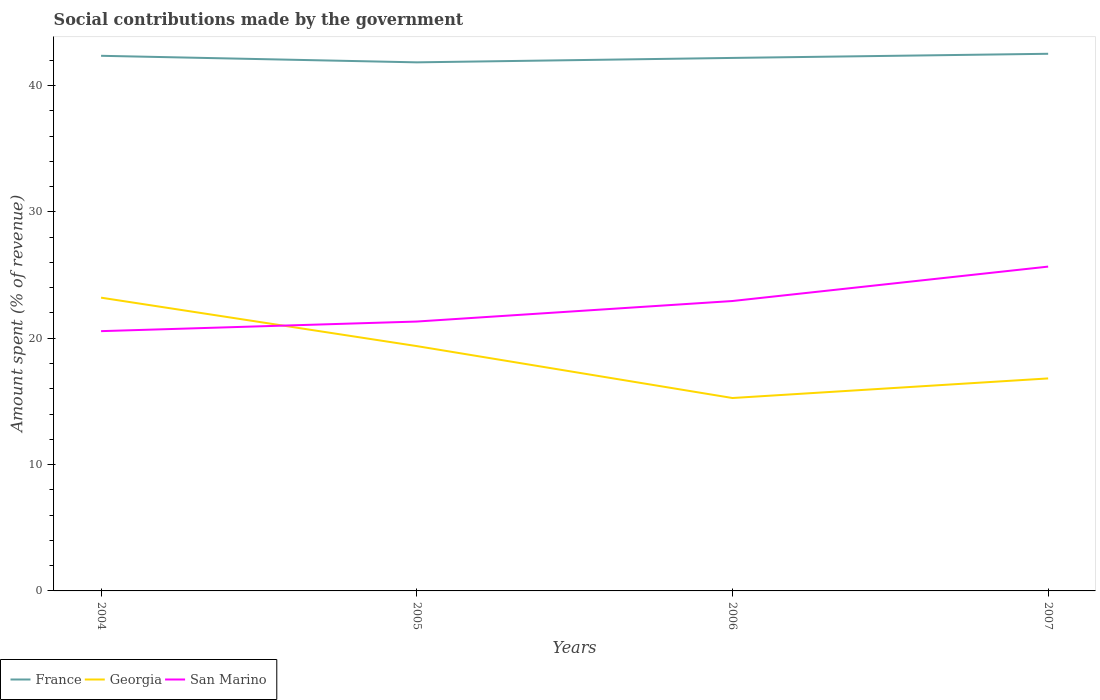How many different coloured lines are there?
Your response must be concise. 3. Is the number of lines equal to the number of legend labels?
Give a very brief answer. Yes. Across all years, what is the maximum amount spent (in %) on social contributions in Georgia?
Keep it short and to the point. 15.27. In which year was the amount spent (in %) on social contributions in San Marino maximum?
Give a very brief answer. 2004. What is the total amount spent (in %) on social contributions in France in the graph?
Ensure brevity in your answer.  -0.16. What is the difference between the highest and the second highest amount spent (in %) on social contributions in San Marino?
Provide a short and direct response. 5.11. What is the difference between the highest and the lowest amount spent (in %) on social contributions in France?
Make the answer very short. 2. What is the difference between two consecutive major ticks on the Y-axis?
Offer a terse response. 10. Does the graph contain grids?
Make the answer very short. No. How many legend labels are there?
Offer a terse response. 3. What is the title of the graph?
Ensure brevity in your answer.  Social contributions made by the government. What is the label or title of the X-axis?
Ensure brevity in your answer.  Years. What is the label or title of the Y-axis?
Your answer should be very brief. Amount spent (% of revenue). What is the Amount spent (% of revenue) of France in 2004?
Offer a terse response. 42.35. What is the Amount spent (% of revenue) of Georgia in 2004?
Your answer should be very brief. 23.21. What is the Amount spent (% of revenue) of San Marino in 2004?
Offer a terse response. 20.56. What is the Amount spent (% of revenue) of France in 2005?
Provide a succinct answer. 41.83. What is the Amount spent (% of revenue) of Georgia in 2005?
Keep it short and to the point. 19.38. What is the Amount spent (% of revenue) of San Marino in 2005?
Ensure brevity in your answer.  21.32. What is the Amount spent (% of revenue) in France in 2006?
Your answer should be very brief. 42.18. What is the Amount spent (% of revenue) in Georgia in 2006?
Your answer should be very brief. 15.27. What is the Amount spent (% of revenue) in San Marino in 2006?
Provide a succinct answer. 22.94. What is the Amount spent (% of revenue) of France in 2007?
Provide a succinct answer. 42.51. What is the Amount spent (% of revenue) in Georgia in 2007?
Your response must be concise. 16.82. What is the Amount spent (% of revenue) in San Marino in 2007?
Offer a terse response. 25.67. Across all years, what is the maximum Amount spent (% of revenue) of France?
Offer a terse response. 42.51. Across all years, what is the maximum Amount spent (% of revenue) in Georgia?
Ensure brevity in your answer.  23.21. Across all years, what is the maximum Amount spent (% of revenue) in San Marino?
Give a very brief answer. 25.67. Across all years, what is the minimum Amount spent (% of revenue) in France?
Keep it short and to the point. 41.83. Across all years, what is the minimum Amount spent (% of revenue) in Georgia?
Offer a terse response. 15.27. Across all years, what is the minimum Amount spent (% of revenue) of San Marino?
Your answer should be very brief. 20.56. What is the total Amount spent (% of revenue) in France in the graph?
Keep it short and to the point. 168.88. What is the total Amount spent (% of revenue) of Georgia in the graph?
Ensure brevity in your answer.  74.67. What is the total Amount spent (% of revenue) in San Marino in the graph?
Your answer should be compact. 90.49. What is the difference between the Amount spent (% of revenue) in France in 2004 and that in 2005?
Offer a terse response. 0.52. What is the difference between the Amount spent (% of revenue) of Georgia in 2004 and that in 2005?
Your answer should be very brief. 3.83. What is the difference between the Amount spent (% of revenue) of San Marino in 2004 and that in 2005?
Provide a succinct answer. -0.76. What is the difference between the Amount spent (% of revenue) in France in 2004 and that in 2006?
Keep it short and to the point. 0.17. What is the difference between the Amount spent (% of revenue) of Georgia in 2004 and that in 2006?
Your answer should be very brief. 7.94. What is the difference between the Amount spent (% of revenue) of San Marino in 2004 and that in 2006?
Make the answer very short. -2.39. What is the difference between the Amount spent (% of revenue) of France in 2004 and that in 2007?
Keep it short and to the point. -0.16. What is the difference between the Amount spent (% of revenue) in Georgia in 2004 and that in 2007?
Offer a terse response. 6.39. What is the difference between the Amount spent (% of revenue) in San Marino in 2004 and that in 2007?
Offer a very short reply. -5.11. What is the difference between the Amount spent (% of revenue) in France in 2005 and that in 2006?
Provide a short and direct response. -0.35. What is the difference between the Amount spent (% of revenue) of Georgia in 2005 and that in 2006?
Offer a very short reply. 4.11. What is the difference between the Amount spent (% of revenue) in San Marino in 2005 and that in 2006?
Your response must be concise. -1.62. What is the difference between the Amount spent (% of revenue) of France in 2005 and that in 2007?
Provide a short and direct response. -0.68. What is the difference between the Amount spent (% of revenue) in Georgia in 2005 and that in 2007?
Your response must be concise. 2.56. What is the difference between the Amount spent (% of revenue) in San Marino in 2005 and that in 2007?
Provide a succinct answer. -4.35. What is the difference between the Amount spent (% of revenue) in France in 2006 and that in 2007?
Give a very brief answer. -0.33. What is the difference between the Amount spent (% of revenue) in Georgia in 2006 and that in 2007?
Your response must be concise. -1.55. What is the difference between the Amount spent (% of revenue) in San Marino in 2006 and that in 2007?
Your answer should be very brief. -2.72. What is the difference between the Amount spent (% of revenue) of France in 2004 and the Amount spent (% of revenue) of Georgia in 2005?
Your answer should be very brief. 22.98. What is the difference between the Amount spent (% of revenue) in France in 2004 and the Amount spent (% of revenue) in San Marino in 2005?
Offer a terse response. 21.03. What is the difference between the Amount spent (% of revenue) of Georgia in 2004 and the Amount spent (% of revenue) of San Marino in 2005?
Give a very brief answer. 1.89. What is the difference between the Amount spent (% of revenue) in France in 2004 and the Amount spent (% of revenue) in Georgia in 2006?
Offer a terse response. 27.08. What is the difference between the Amount spent (% of revenue) of France in 2004 and the Amount spent (% of revenue) of San Marino in 2006?
Ensure brevity in your answer.  19.41. What is the difference between the Amount spent (% of revenue) of Georgia in 2004 and the Amount spent (% of revenue) of San Marino in 2006?
Offer a very short reply. 0.27. What is the difference between the Amount spent (% of revenue) in France in 2004 and the Amount spent (% of revenue) in Georgia in 2007?
Your response must be concise. 25.53. What is the difference between the Amount spent (% of revenue) in France in 2004 and the Amount spent (% of revenue) in San Marino in 2007?
Give a very brief answer. 16.68. What is the difference between the Amount spent (% of revenue) in Georgia in 2004 and the Amount spent (% of revenue) in San Marino in 2007?
Provide a succinct answer. -2.46. What is the difference between the Amount spent (% of revenue) of France in 2005 and the Amount spent (% of revenue) of Georgia in 2006?
Your response must be concise. 26.57. What is the difference between the Amount spent (% of revenue) of France in 2005 and the Amount spent (% of revenue) of San Marino in 2006?
Keep it short and to the point. 18.89. What is the difference between the Amount spent (% of revenue) of Georgia in 2005 and the Amount spent (% of revenue) of San Marino in 2006?
Give a very brief answer. -3.57. What is the difference between the Amount spent (% of revenue) in France in 2005 and the Amount spent (% of revenue) in Georgia in 2007?
Provide a succinct answer. 25.02. What is the difference between the Amount spent (% of revenue) of France in 2005 and the Amount spent (% of revenue) of San Marino in 2007?
Provide a succinct answer. 16.17. What is the difference between the Amount spent (% of revenue) in Georgia in 2005 and the Amount spent (% of revenue) in San Marino in 2007?
Keep it short and to the point. -6.29. What is the difference between the Amount spent (% of revenue) of France in 2006 and the Amount spent (% of revenue) of Georgia in 2007?
Offer a very short reply. 25.37. What is the difference between the Amount spent (% of revenue) of France in 2006 and the Amount spent (% of revenue) of San Marino in 2007?
Provide a succinct answer. 16.52. What is the difference between the Amount spent (% of revenue) in Georgia in 2006 and the Amount spent (% of revenue) in San Marino in 2007?
Offer a very short reply. -10.4. What is the average Amount spent (% of revenue) in France per year?
Give a very brief answer. 42.22. What is the average Amount spent (% of revenue) in Georgia per year?
Keep it short and to the point. 18.67. What is the average Amount spent (% of revenue) in San Marino per year?
Your answer should be very brief. 22.62. In the year 2004, what is the difference between the Amount spent (% of revenue) of France and Amount spent (% of revenue) of Georgia?
Keep it short and to the point. 19.14. In the year 2004, what is the difference between the Amount spent (% of revenue) in France and Amount spent (% of revenue) in San Marino?
Give a very brief answer. 21.79. In the year 2004, what is the difference between the Amount spent (% of revenue) of Georgia and Amount spent (% of revenue) of San Marino?
Offer a very short reply. 2.65. In the year 2005, what is the difference between the Amount spent (% of revenue) in France and Amount spent (% of revenue) in Georgia?
Your answer should be compact. 22.46. In the year 2005, what is the difference between the Amount spent (% of revenue) in France and Amount spent (% of revenue) in San Marino?
Provide a short and direct response. 20.51. In the year 2005, what is the difference between the Amount spent (% of revenue) in Georgia and Amount spent (% of revenue) in San Marino?
Keep it short and to the point. -1.94. In the year 2006, what is the difference between the Amount spent (% of revenue) of France and Amount spent (% of revenue) of Georgia?
Your response must be concise. 26.92. In the year 2006, what is the difference between the Amount spent (% of revenue) of France and Amount spent (% of revenue) of San Marino?
Make the answer very short. 19.24. In the year 2006, what is the difference between the Amount spent (% of revenue) of Georgia and Amount spent (% of revenue) of San Marino?
Keep it short and to the point. -7.68. In the year 2007, what is the difference between the Amount spent (% of revenue) of France and Amount spent (% of revenue) of Georgia?
Provide a succinct answer. 25.69. In the year 2007, what is the difference between the Amount spent (% of revenue) in France and Amount spent (% of revenue) in San Marino?
Your answer should be very brief. 16.84. In the year 2007, what is the difference between the Amount spent (% of revenue) of Georgia and Amount spent (% of revenue) of San Marino?
Give a very brief answer. -8.85. What is the ratio of the Amount spent (% of revenue) in France in 2004 to that in 2005?
Provide a succinct answer. 1.01. What is the ratio of the Amount spent (% of revenue) of Georgia in 2004 to that in 2005?
Provide a succinct answer. 1.2. What is the ratio of the Amount spent (% of revenue) in France in 2004 to that in 2006?
Make the answer very short. 1. What is the ratio of the Amount spent (% of revenue) of Georgia in 2004 to that in 2006?
Provide a succinct answer. 1.52. What is the ratio of the Amount spent (% of revenue) in San Marino in 2004 to that in 2006?
Offer a very short reply. 0.9. What is the ratio of the Amount spent (% of revenue) of Georgia in 2004 to that in 2007?
Your answer should be very brief. 1.38. What is the ratio of the Amount spent (% of revenue) of San Marino in 2004 to that in 2007?
Give a very brief answer. 0.8. What is the ratio of the Amount spent (% of revenue) of Georgia in 2005 to that in 2006?
Make the answer very short. 1.27. What is the ratio of the Amount spent (% of revenue) in San Marino in 2005 to that in 2006?
Provide a short and direct response. 0.93. What is the ratio of the Amount spent (% of revenue) of France in 2005 to that in 2007?
Your answer should be compact. 0.98. What is the ratio of the Amount spent (% of revenue) in Georgia in 2005 to that in 2007?
Ensure brevity in your answer.  1.15. What is the ratio of the Amount spent (% of revenue) in San Marino in 2005 to that in 2007?
Your response must be concise. 0.83. What is the ratio of the Amount spent (% of revenue) in Georgia in 2006 to that in 2007?
Offer a very short reply. 0.91. What is the ratio of the Amount spent (% of revenue) of San Marino in 2006 to that in 2007?
Give a very brief answer. 0.89. What is the difference between the highest and the second highest Amount spent (% of revenue) of France?
Offer a very short reply. 0.16. What is the difference between the highest and the second highest Amount spent (% of revenue) in Georgia?
Your answer should be compact. 3.83. What is the difference between the highest and the second highest Amount spent (% of revenue) of San Marino?
Provide a short and direct response. 2.72. What is the difference between the highest and the lowest Amount spent (% of revenue) of France?
Offer a very short reply. 0.68. What is the difference between the highest and the lowest Amount spent (% of revenue) of Georgia?
Ensure brevity in your answer.  7.94. What is the difference between the highest and the lowest Amount spent (% of revenue) of San Marino?
Your response must be concise. 5.11. 